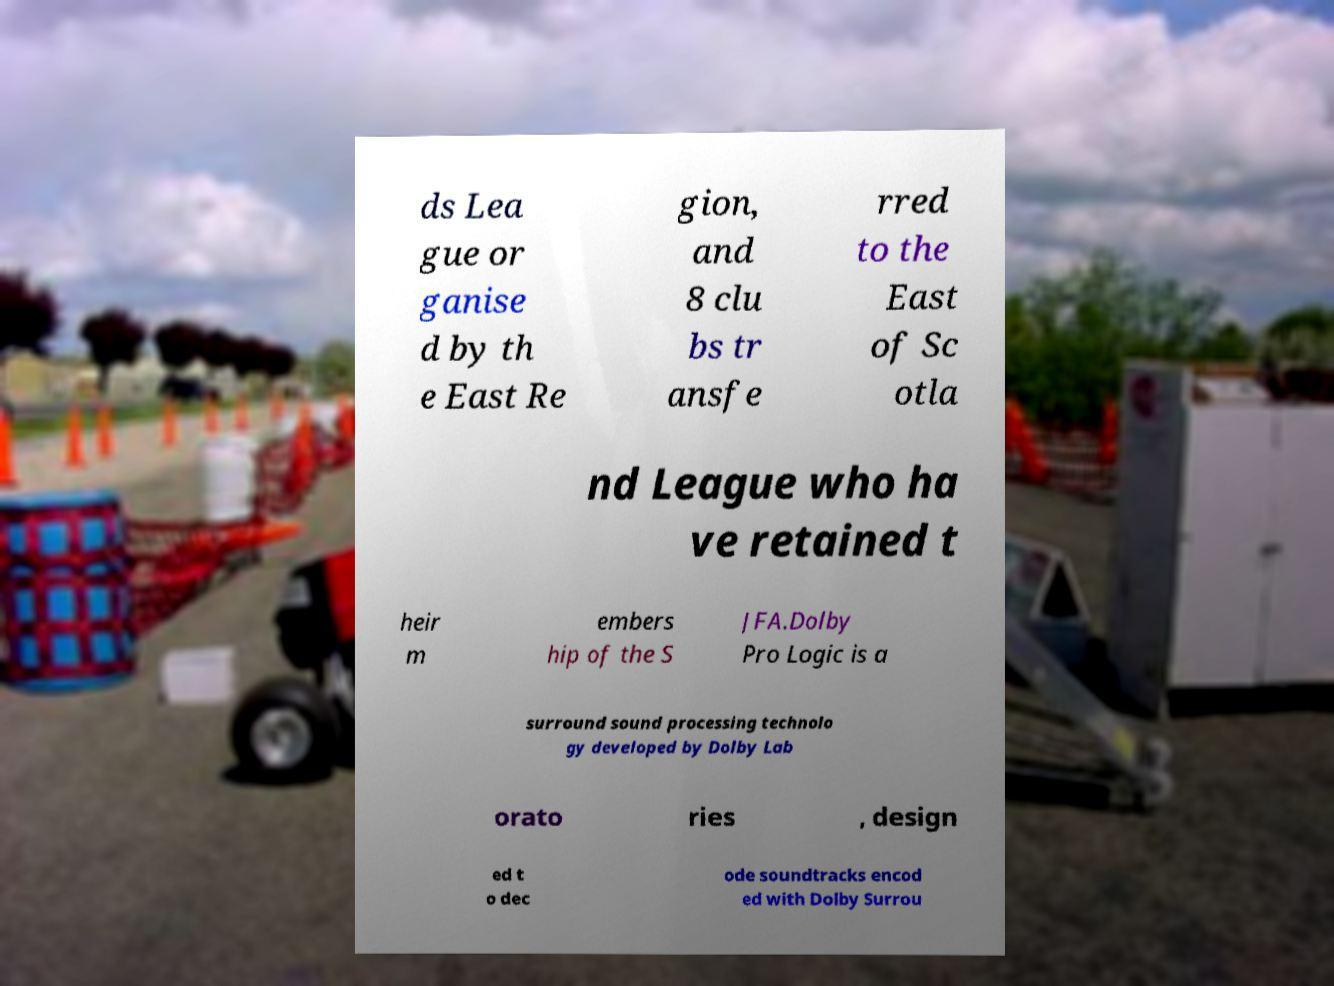What messages or text are displayed in this image? I need them in a readable, typed format. ds Lea gue or ganise d by th e East Re gion, and 8 clu bs tr ansfe rred to the East of Sc otla nd League who ha ve retained t heir m embers hip of the S JFA.Dolby Pro Logic is a surround sound processing technolo gy developed by Dolby Lab orato ries , design ed t o dec ode soundtracks encod ed with Dolby Surrou 